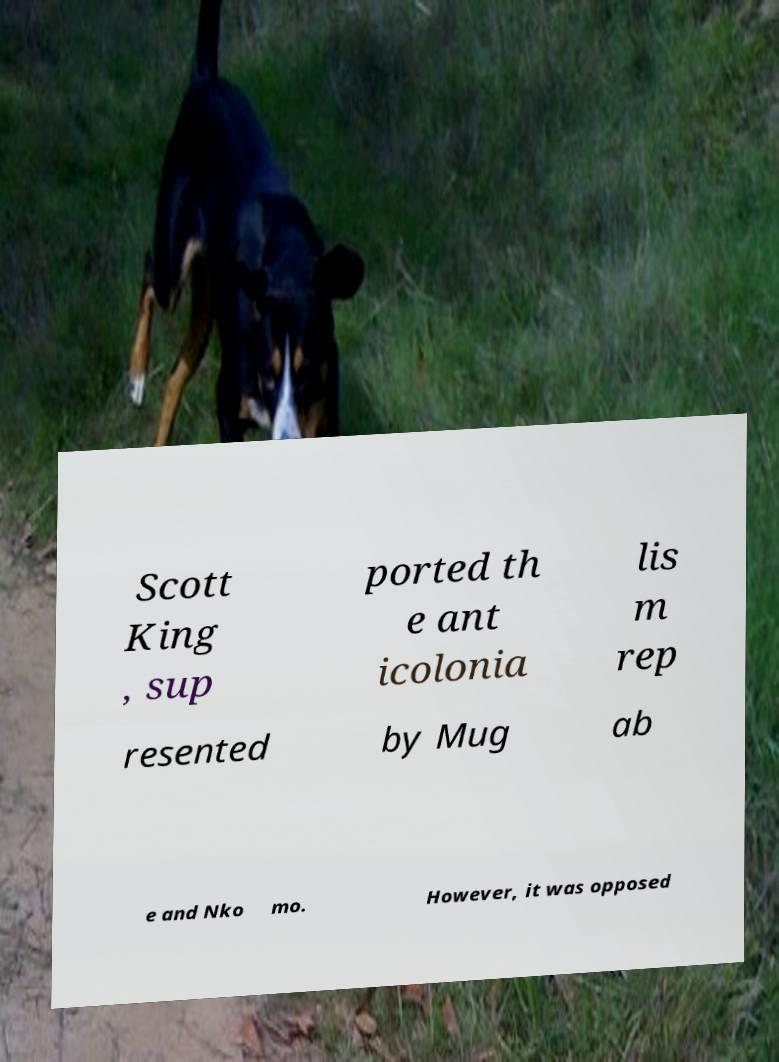Please read and relay the text visible in this image. What does it say? Scott King , sup ported th e ant icolonia lis m rep resented by Mug ab e and Nko mo. However, it was opposed 